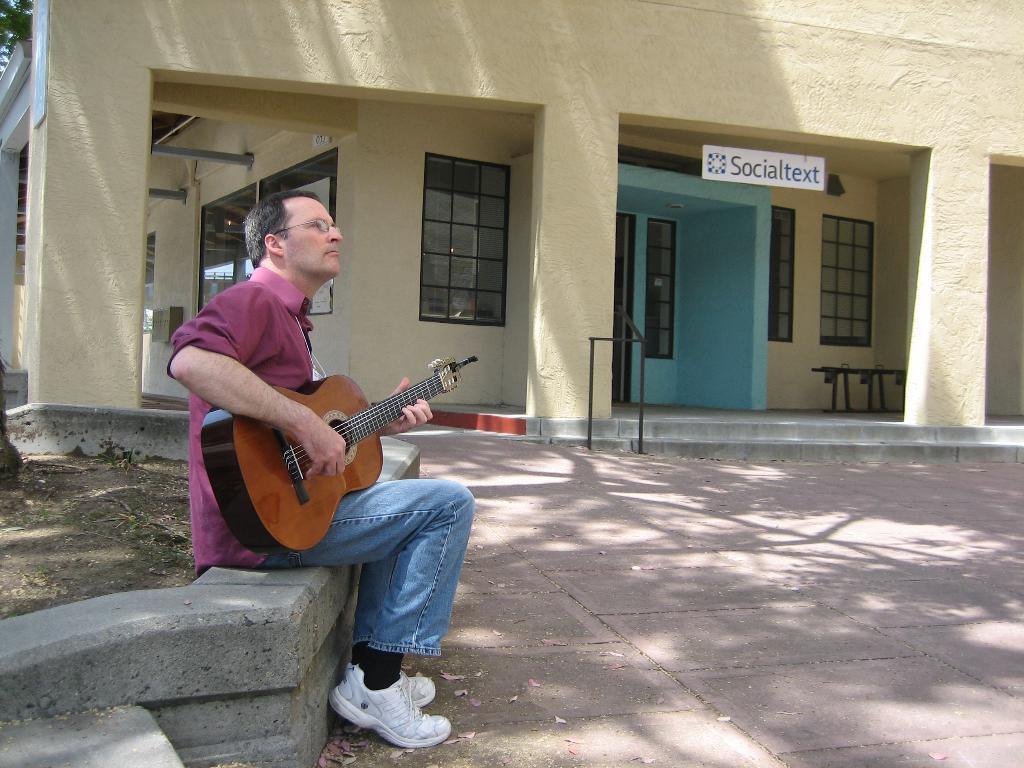What type of structure can be seen in the background of the image? There is a building in the background of the image. What features does the building have? The building has a door and windows. What is placed in front of the building? There is a board in front of the building. What is the man in front of the building doing? The man is sitting in front of the building and playing a guitar. How many dimes can be seen on the man's fingers while he is playing the guitar? There are no dimes visible on the man's fingers in the image. Can you tell me how many cows are grazing behind the building? There are no cows present in the image; it only features a building, a board, and a man playing a guitar. 